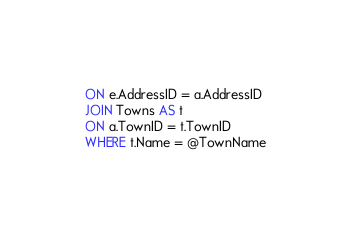<code> <loc_0><loc_0><loc_500><loc_500><_SQL_>ON e.AddressID = a.AddressID
JOIN Towns AS t
ON a.TownID = t.TownID
WHERE t.Name = @TownName
</code> 